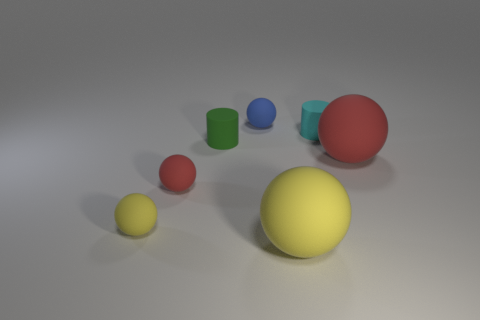Add 2 tiny cyan rubber blocks. How many objects exist? 9 Subtract all yellow balls. How many balls are left? 3 Subtract 4 balls. How many balls are left? 1 Subtract all red spheres. How many spheres are left? 3 Subtract all small blue rubber balls. Subtract all blue rubber things. How many objects are left? 5 Add 4 cyan cylinders. How many cyan cylinders are left? 5 Add 3 small green cylinders. How many small green cylinders exist? 4 Subtract 1 cyan cylinders. How many objects are left? 6 Subtract all spheres. How many objects are left? 2 Subtract all brown balls. Subtract all yellow blocks. How many balls are left? 5 